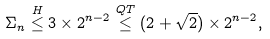Convert formula to latex. <formula><loc_0><loc_0><loc_500><loc_500>\Sigma _ { n } \stackrel { H } { \leq } 3 \times 2 ^ { n - 2 } \stackrel { Q T } { \leq } ( 2 + \sqrt { 2 } ) \times 2 ^ { n - 2 } ,</formula> 